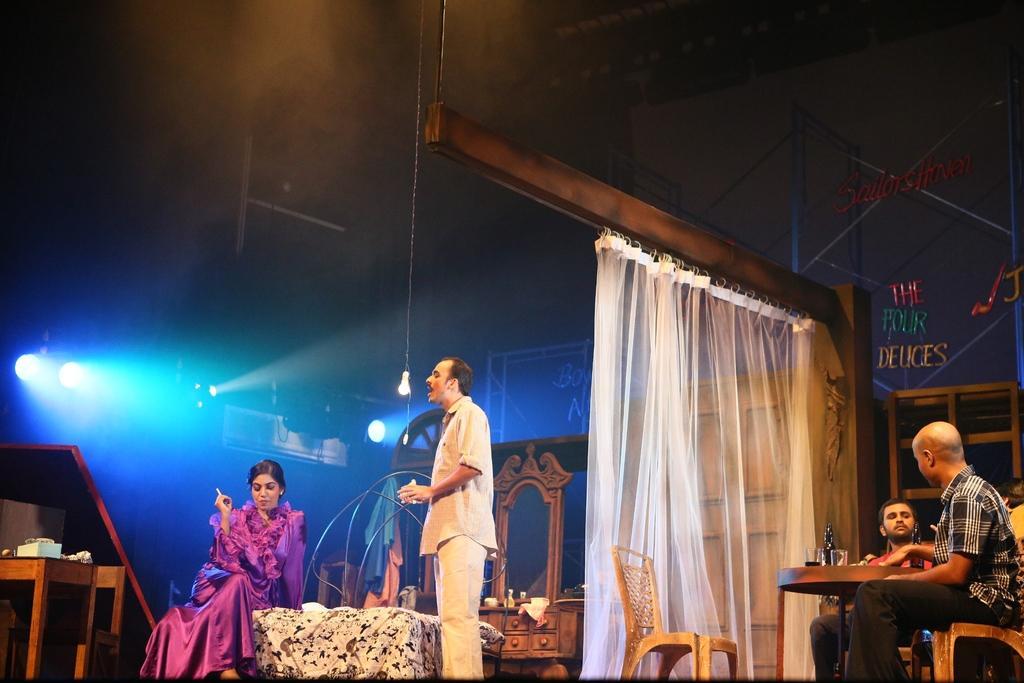How would you summarize this image in a sentence or two? In this image in the front there are persons standing and sitting and there is an empty chair. In the center there is a curtain which is white in colour and there is a light hanging. In the background there are lights and there are boards with some text written on it. On the left side there is stand and on the stand there is an object which is white in colour. 